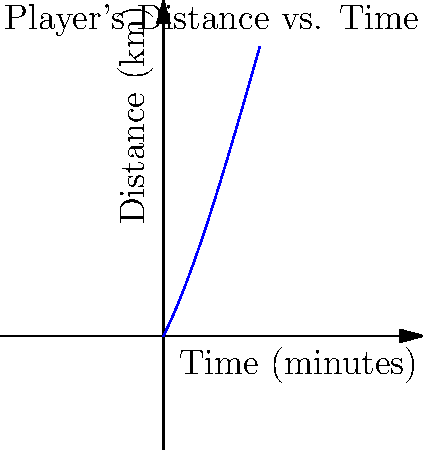As a women's soccer commentator in Ontario, you're analyzing a player's performance during a match. The graph shows the relationship between the time played and the distance covered by a star midfielder. If the polynomial function representing this relationship is $d(t) = -0.005t^3 + 0.15t^2 + 2t$, where $d$ is the distance in kilometers and $t$ is the time in minutes, at what time does the player reach her maximum speed? To find the time when the player reaches her maximum speed, we need to follow these steps:

1) The speed is the rate of change of distance with respect to time, which is the first derivative of the distance function.

2) Let's find the first derivative of $d(t)$:
   $d'(t) = -0.015t^2 + 0.3t + 2$

3) The maximum speed occurs when the acceleration (rate of change of speed) is zero. This is when the second derivative equals zero.

4) Let's find the second derivative:
   $d''(t) = -0.03t + 0.3$

5) Set this equal to zero and solve for $t$:
   $-0.03t + 0.3 = 0$
   $-0.03t = -0.3$
   $t = 10$

6) To confirm this is a maximum (not a minimum), we can check that $d'''(t) = -0.03$, which is negative, indicating a maximum.

Therefore, the player reaches her maximum speed at $t = 10$ minutes.
Answer: 10 minutes 